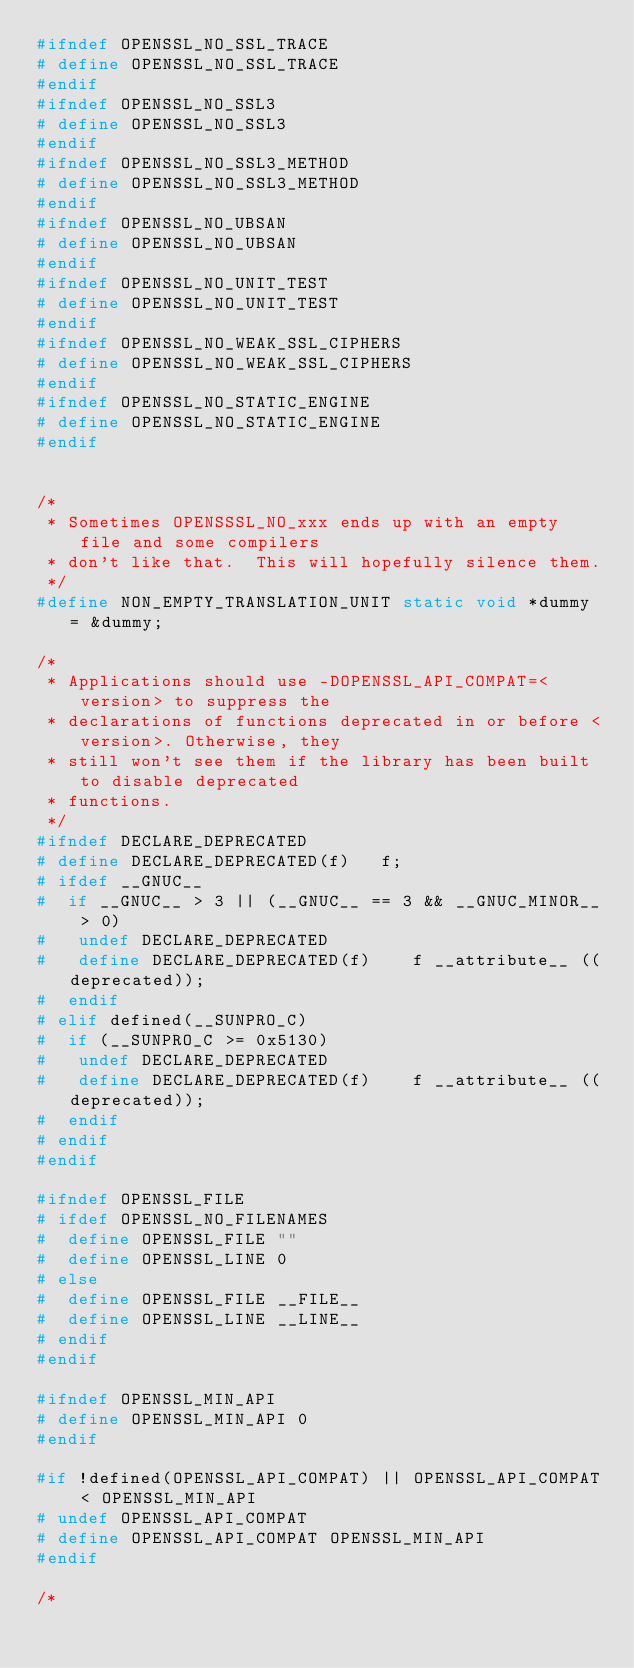<code> <loc_0><loc_0><loc_500><loc_500><_C_>#ifndef OPENSSL_NO_SSL_TRACE
# define OPENSSL_NO_SSL_TRACE
#endif
#ifndef OPENSSL_NO_SSL3
# define OPENSSL_NO_SSL3
#endif
#ifndef OPENSSL_NO_SSL3_METHOD
# define OPENSSL_NO_SSL3_METHOD
#endif
#ifndef OPENSSL_NO_UBSAN
# define OPENSSL_NO_UBSAN
#endif
#ifndef OPENSSL_NO_UNIT_TEST
# define OPENSSL_NO_UNIT_TEST
#endif
#ifndef OPENSSL_NO_WEAK_SSL_CIPHERS
# define OPENSSL_NO_WEAK_SSL_CIPHERS
#endif
#ifndef OPENSSL_NO_STATIC_ENGINE
# define OPENSSL_NO_STATIC_ENGINE
#endif


/*
 * Sometimes OPENSSSL_NO_xxx ends up with an empty file and some compilers
 * don't like that.  This will hopefully silence them.
 */
#define NON_EMPTY_TRANSLATION_UNIT static void *dummy = &dummy;

/*
 * Applications should use -DOPENSSL_API_COMPAT=<version> to suppress the
 * declarations of functions deprecated in or before <version>. Otherwise, they
 * still won't see them if the library has been built to disable deprecated
 * functions.
 */
#ifndef DECLARE_DEPRECATED
# define DECLARE_DEPRECATED(f)   f;
# ifdef __GNUC__
#  if __GNUC__ > 3 || (__GNUC__ == 3 && __GNUC_MINOR__ > 0)
#   undef DECLARE_DEPRECATED
#   define DECLARE_DEPRECATED(f)    f __attribute__ ((deprecated));
#  endif
# elif defined(__SUNPRO_C)
#  if (__SUNPRO_C >= 0x5130)
#   undef DECLARE_DEPRECATED
#   define DECLARE_DEPRECATED(f)    f __attribute__ ((deprecated));
#  endif
# endif
#endif

#ifndef OPENSSL_FILE
# ifdef OPENSSL_NO_FILENAMES
#  define OPENSSL_FILE ""
#  define OPENSSL_LINE 0
# else
#  define OPENSSL_FILE __FILE__
#  define OPENSSL_LINE __LINE__
# endif
#endif

#ifndef OPENSSL_MIN_API
# define OPENSSL_MIN_API 0
#endif

#if !defined(OPENSSL_API_COMPAT) || OPENSSL_API_COMPAT < OPENSSL_MIN_API
# undef OPENSSL_API_COMPAT
# define OPENSSL_API_COMPAT OPENSSL_MIN_API
#endif

/*</code> 